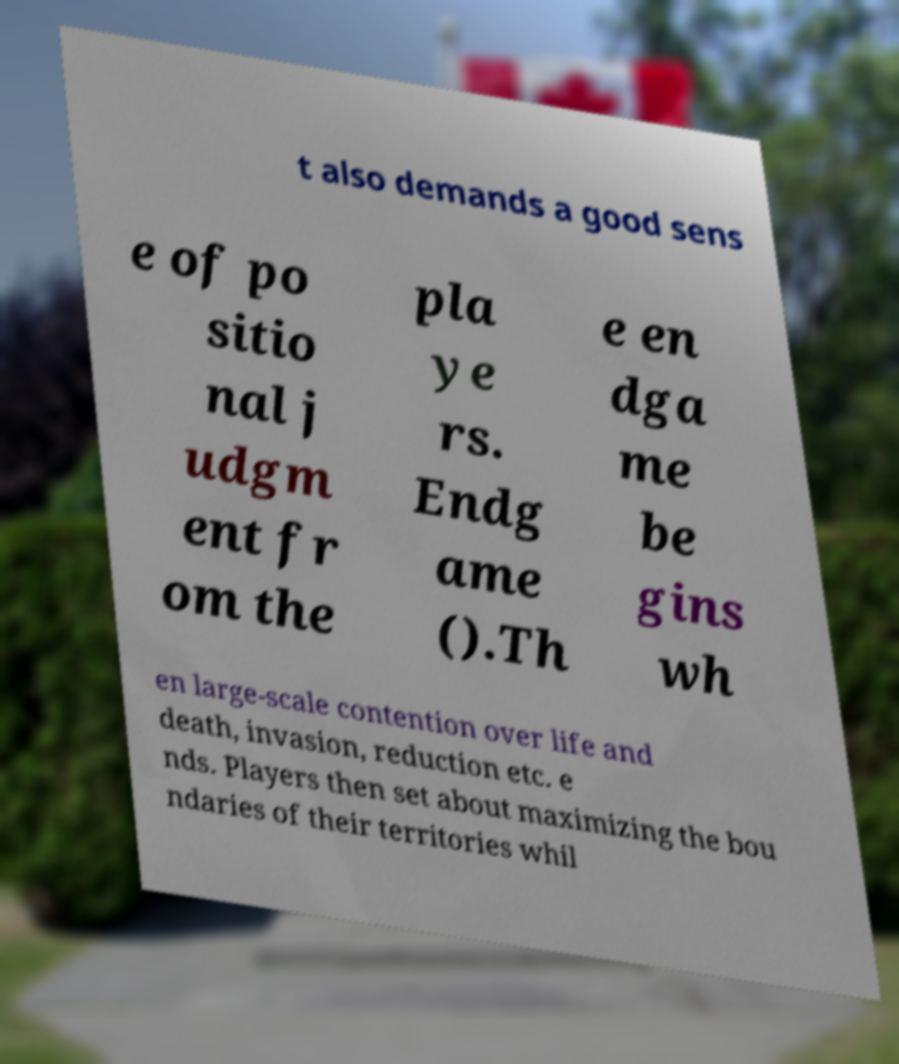There's text embedded in this image that I need extracted. Can you transcribe it verbatim? t also demands a good sens e of po sitio nal j udgm ent fr om the pla ye rs. Endg ame ().Th e en dga me be gins wh en large-scale contention over life and death, invasion, reduction etc. e nds. Players then set about maximizing the bou ndaries of their territories whil 